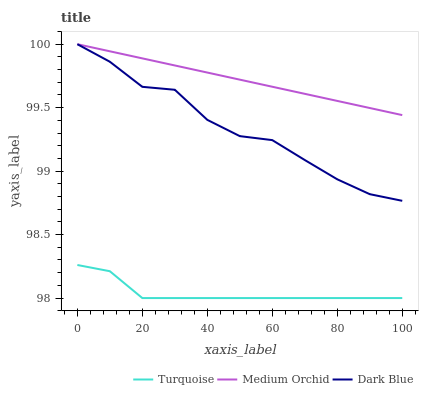Does Turquoise have the minimum area under the curve?
Answer yes or no. Yes. Does Medium Orchid have the maximum area under the curve?
Answer yes or no. Yes. Does Medium Orchid have the minimum area under the curve?
Answer yes or no. No. Does Turquoise have the maximum area under the curve?
Answer yes or no. No. Is Medium Orchid the smoothest?
Answer yes or no. Yes. Is Dark Blue the roughest?
Answer yes or no. Yes. Is Turquoise the smoothest?
Answer yes or no. No. Is Turquoise the roughest?
Answer yes or no. No. Does Medium Orchid have the lowest value?
Answer yes or no. No. Does Medium Orchid have the highest value?
Answer yes or no. Yes. Does Turquoise have the highest value?
Answer yes or no. No. Is Turquoise less than Dark Blue?
Answer yes or no. Yes. Is Medium Orchid greater than Turquoise?
Answer yes or no. Yes. Does Dark Blue intersect Medium Orchid?
Answer yes or no. Yes. Is Dark Blue less than Medium Orchid?
Answer yes or no. No. Is Dark Blue greater than Medium Orchid?
Answer yes or no. No. Does Turquoise intersect Dark Blue?
Answer yes or no. No. 